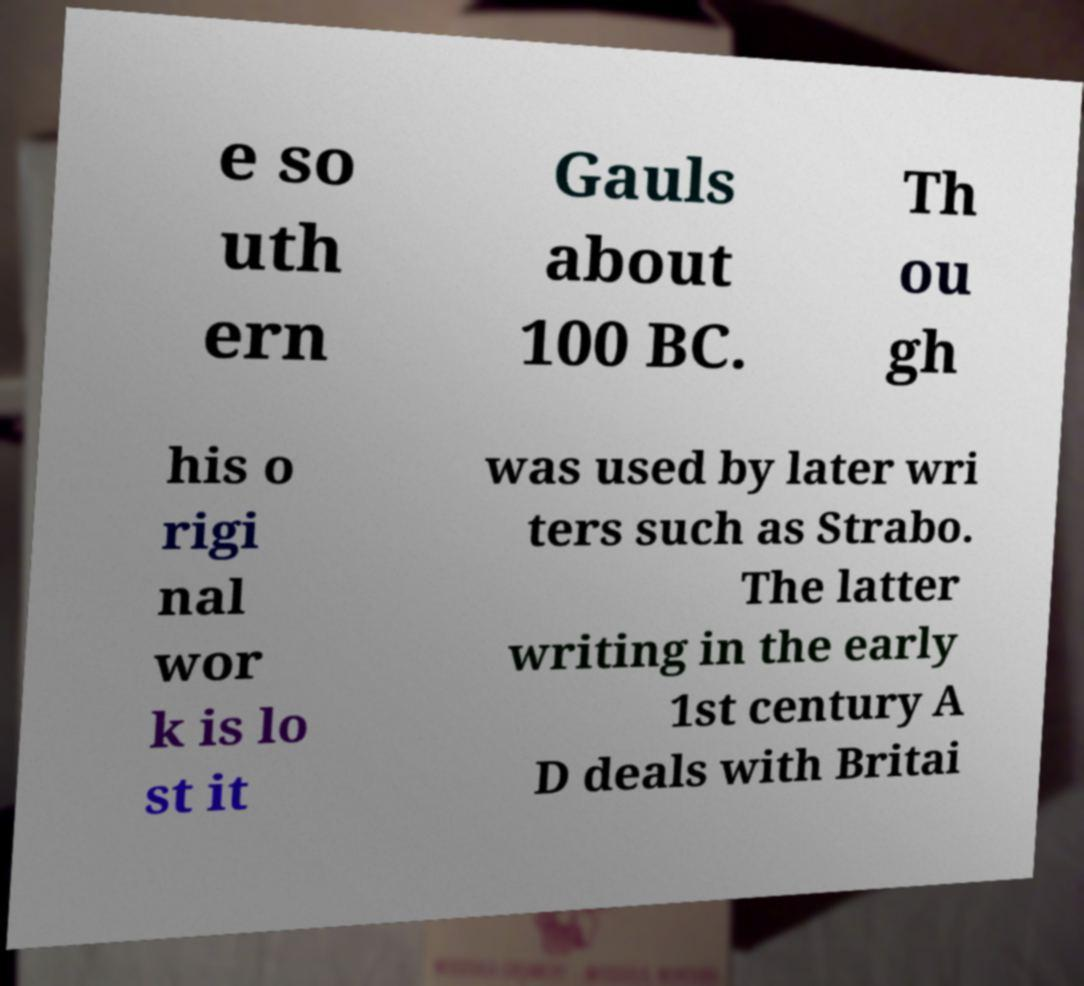There's text embedded in this image that I need extracted. Can you transcribe it verbatim? e so uth ern Gauls about 100 BC. Th ou gh his o rigi nal wor k is lo st it was used by later wri ters such as Strabo. The latter writing in the early 1st century A D deals with Britai 